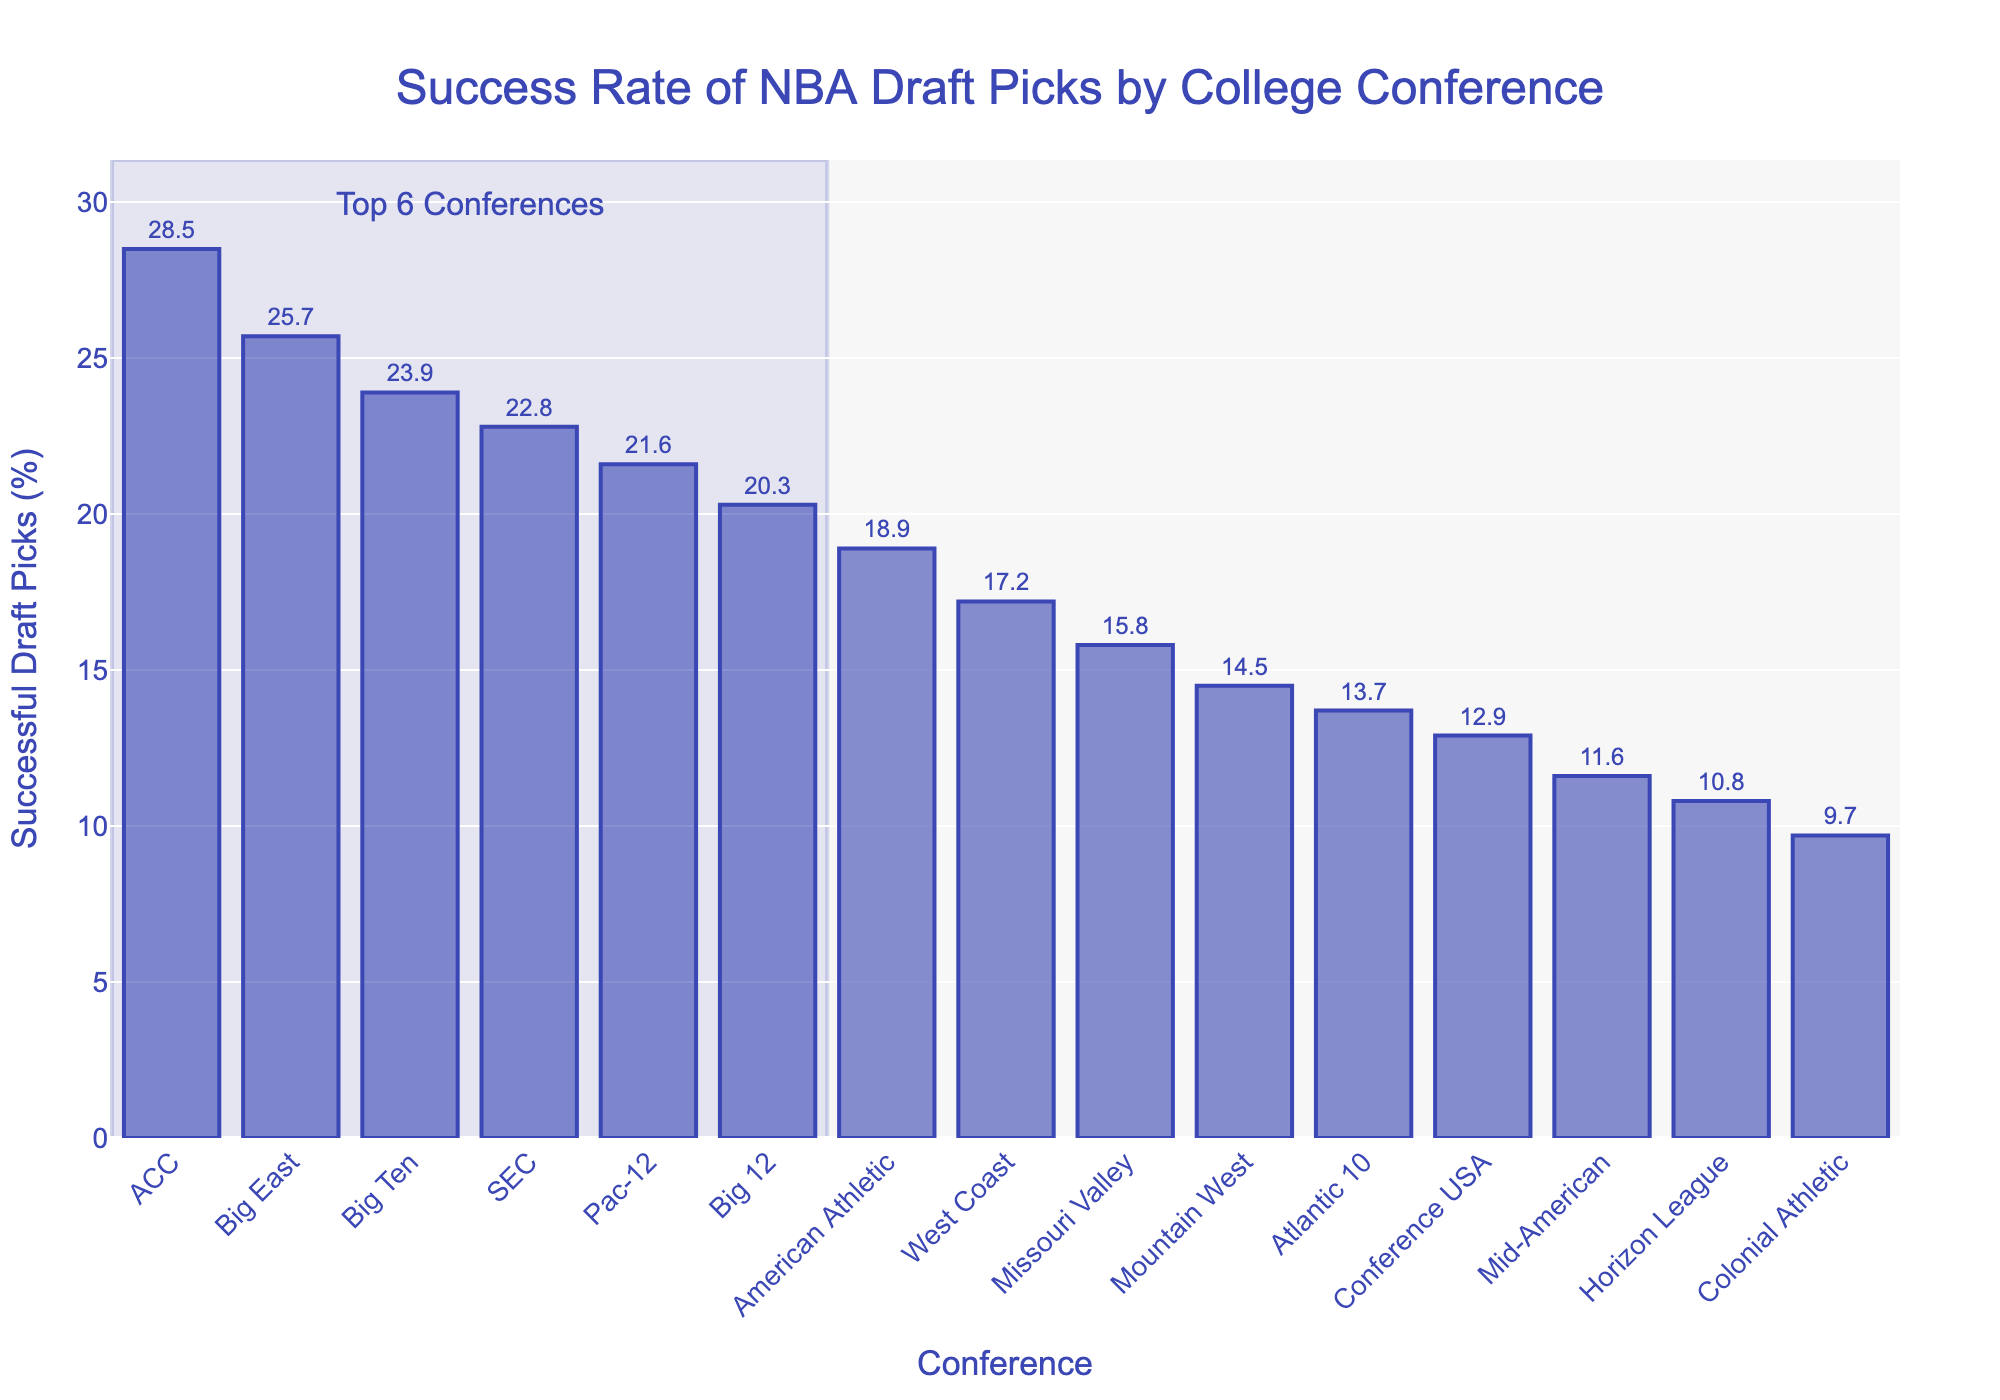Which conference has the highest success rate of NBA draft picks? The conference with the highest bar represents the conference with the highest success rate. According to the chart, the ACC has the highest success rate of NBA draft picks at 28.5%.
Answer: ACC Compare the success rates of the Big Ten and Big 12 conferences. Which one is higher, and by how much? The Big Ten conference has a success rate of 23.9%, while the Big 12 conference has a success rate of 20.3%. The difference is 23.9% - 20.3% = 3.6%.
Answer: Big Ten, by 3.6% Calculate the average success rate of the top 3 conferences. The top 3 conferences are ACC (28.5%), Big East (25.7%), and Big Ten (23.9%). The average is (28.5 + 25.7 + 23.9) / 3 = 26.03%.
Answer: 26.03% Among the SEC, Pac-12, and Big 12 conferences, which one has the lowest success rate of NBA draft picks? The SEC has a success rate of 22.8%, Pac-12 has 21.6%, and Big 12 has 20.3%. The Big 12 conference has the lowest success rate among them.
Answer: Big 12 How many conferences have a success rate higher than 20%? The conferences with success rates higher than 20% are ACC, Big East, Big Ten, SEC, Pac-12, and Big 12. There are 6 such conferences.
Answer: 6 What's the success rate difference between the conference with the highest and the lowest success rate? The highest success rate is for ACC at 28.5% and the lowest is Colonial Athletic at 9.7%. The difference is 28.5% - 9.7% = 18.8%.
Answer: 18.8% What is the success rate of the Missouri Valley conference as depicted in the chart? Refer to the bar labeled "Missouri Valley" to see its height, which shows a success rate of 15.8%.
Answer: 15.8% Are there more conferences with success rates above or below 15%? The conferences with success rates above 15% are ACC, Big East, Big Ten, SEC, Pac-12, Big 12, American Athletic, and West Coast, making a total of 8. The conferences with success rates below 15% are Missouri Valley, Mountain West, Atlantic 10, Conference USA, Mid-American, Horizon League, and Colonial Athletic, making a total of 7. Therefore, there are more conferences with success rates above 15%.
Answer: Above Which conference marks the midpoint of the success rates among listed conferences? There are 15 conferences in total. The midpoint is the 8th conference when sorted by success rate from highest to lowest. The 8th conference is West Coast with a success rate of 17.2%.
Answer: West Coast What's the combined success rate of the SEC and Pac-12 conferences? The SEC has a success rate of 22.8% and Pac-12 has 21.6%. The combined success rate is 22.8% + 21.6% = 44.4%.
Answer: 44.4% 